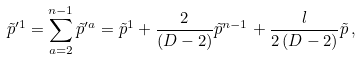Convert formula to latex. <formula><loc_0><loc_0><loc_500><loc_500>\tilde { p } ^ { \prime 1 } = \sum _ { a = 2 } ^ { n - 1 } \tilde { p } ^ { \prime a } = \tilde { p } ^ { 1 } + { \frac { 2 } { ( D - 2 ) } } \tilde { p } ^ { n - 1 } + { \frac { l } { 2 \, ( D - 2 ) } } \tilde { p } \, ,</formula> 